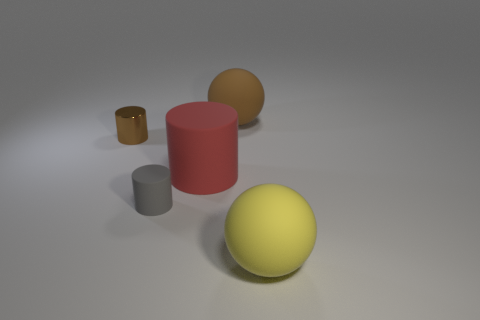Is there any other thing that has the same material as the tiny brown thing?
Keep it short and to the point. No. There is a rubber thing that is the same color as the metal thing; what size is it?
Provide a succinct answer. Large. What is the big object that is in front of the brown ball and left of the yellow matte object made of?
Ensure brevity in your answer.  Rubber. What is the size of the gray rubber cylinder?
Your answer should be compact. Small. What is the color of the small matte object that is the same shape as the small brown shiny object?
Your answer should be very brief. Gray. Are there any other things of the same color as the big cylinder?
Your answer should be very brief. No. There is a sphere on the left side of the yellow object; does it have the same size as the thing on the right side of the big brown sphere?
Keep it short and to the point. Yes. Is the number of big red things behind the brown shiny cylinder the same as the number of small shiny objects in front of the yellow ball?
Offer a very short reply. Yes. Does the brown ball have the same size as the sphere right of the large brown rubber ball?
Ensure brevity in your answer.  Yes. There is a big red cylinder left of the yellow matte thing; are there any small brown objects that are in front of it?
Provide a succinct answer. No. 